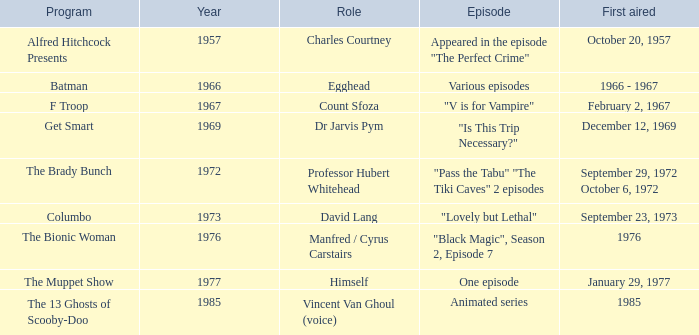Can you parse all the data within this table? {'header': ['Program', 'Year', 'Role', 'Episode', 'First aired'], 'rows': [['Alfred Hitchcock Presents', '1957', 'Charles Courtney', 'Appeared in the episode "The Perfect Crime"', 'October 20, 1957'], ['Batman', '1966', 'Egghead', 'Various episodes', '1966 - 1967'], ['F Troop', '1967', 'Count Sfoza', '"V is for Vampire"', 'February 2, 1967'], ['Get Smart', '1969', 'Dr Jarvis Pym', '"Is This Trip Necessary?"', 'December 12, 1969'], ['The Brady Bunch', '1972', 'Professor Hubert Whitehead', '"Pass the Tabu" "The Tiki Caves" 2 episodes', 'September 29, 1972 October 6, 1972'], ['Columbo', '1973', 'David Lang', '"Lovely but Lethal"', 'September 23, 1973'], ['The Bionic Woman', '1976', 'Manfred / Cyrus Carstairs', '"Black Magic", Season 2, Episode 7', '1976'], ['The Muppet Show', '1977', 'Himself', 'One episode', 'January 29, 1977'], ['The 13 Ghosts of Scooby-Doo', '1985', 'Vincent Van Ghoul (voice)', 'Animated series', '1985']]} What's the roles of the Bionic Woman? Manfred / Cyrus Carstairs. 